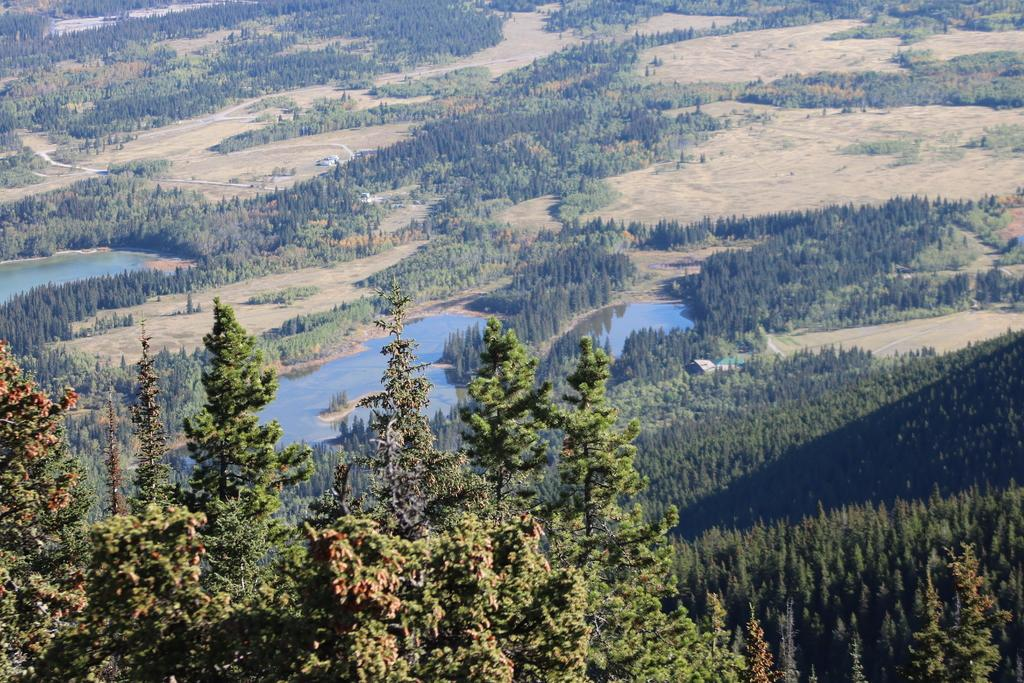What is the primary feature of the image? The primary feature of the image is the presence of many trees. Can you describe the water in the image? Yes, there is water in the middle of the image. How does the water support the trees in the image? The water does not support the trees in the image; it is a separate feature in the middle of the image. What type of square can be seen in the image? There is no square present in the image. 